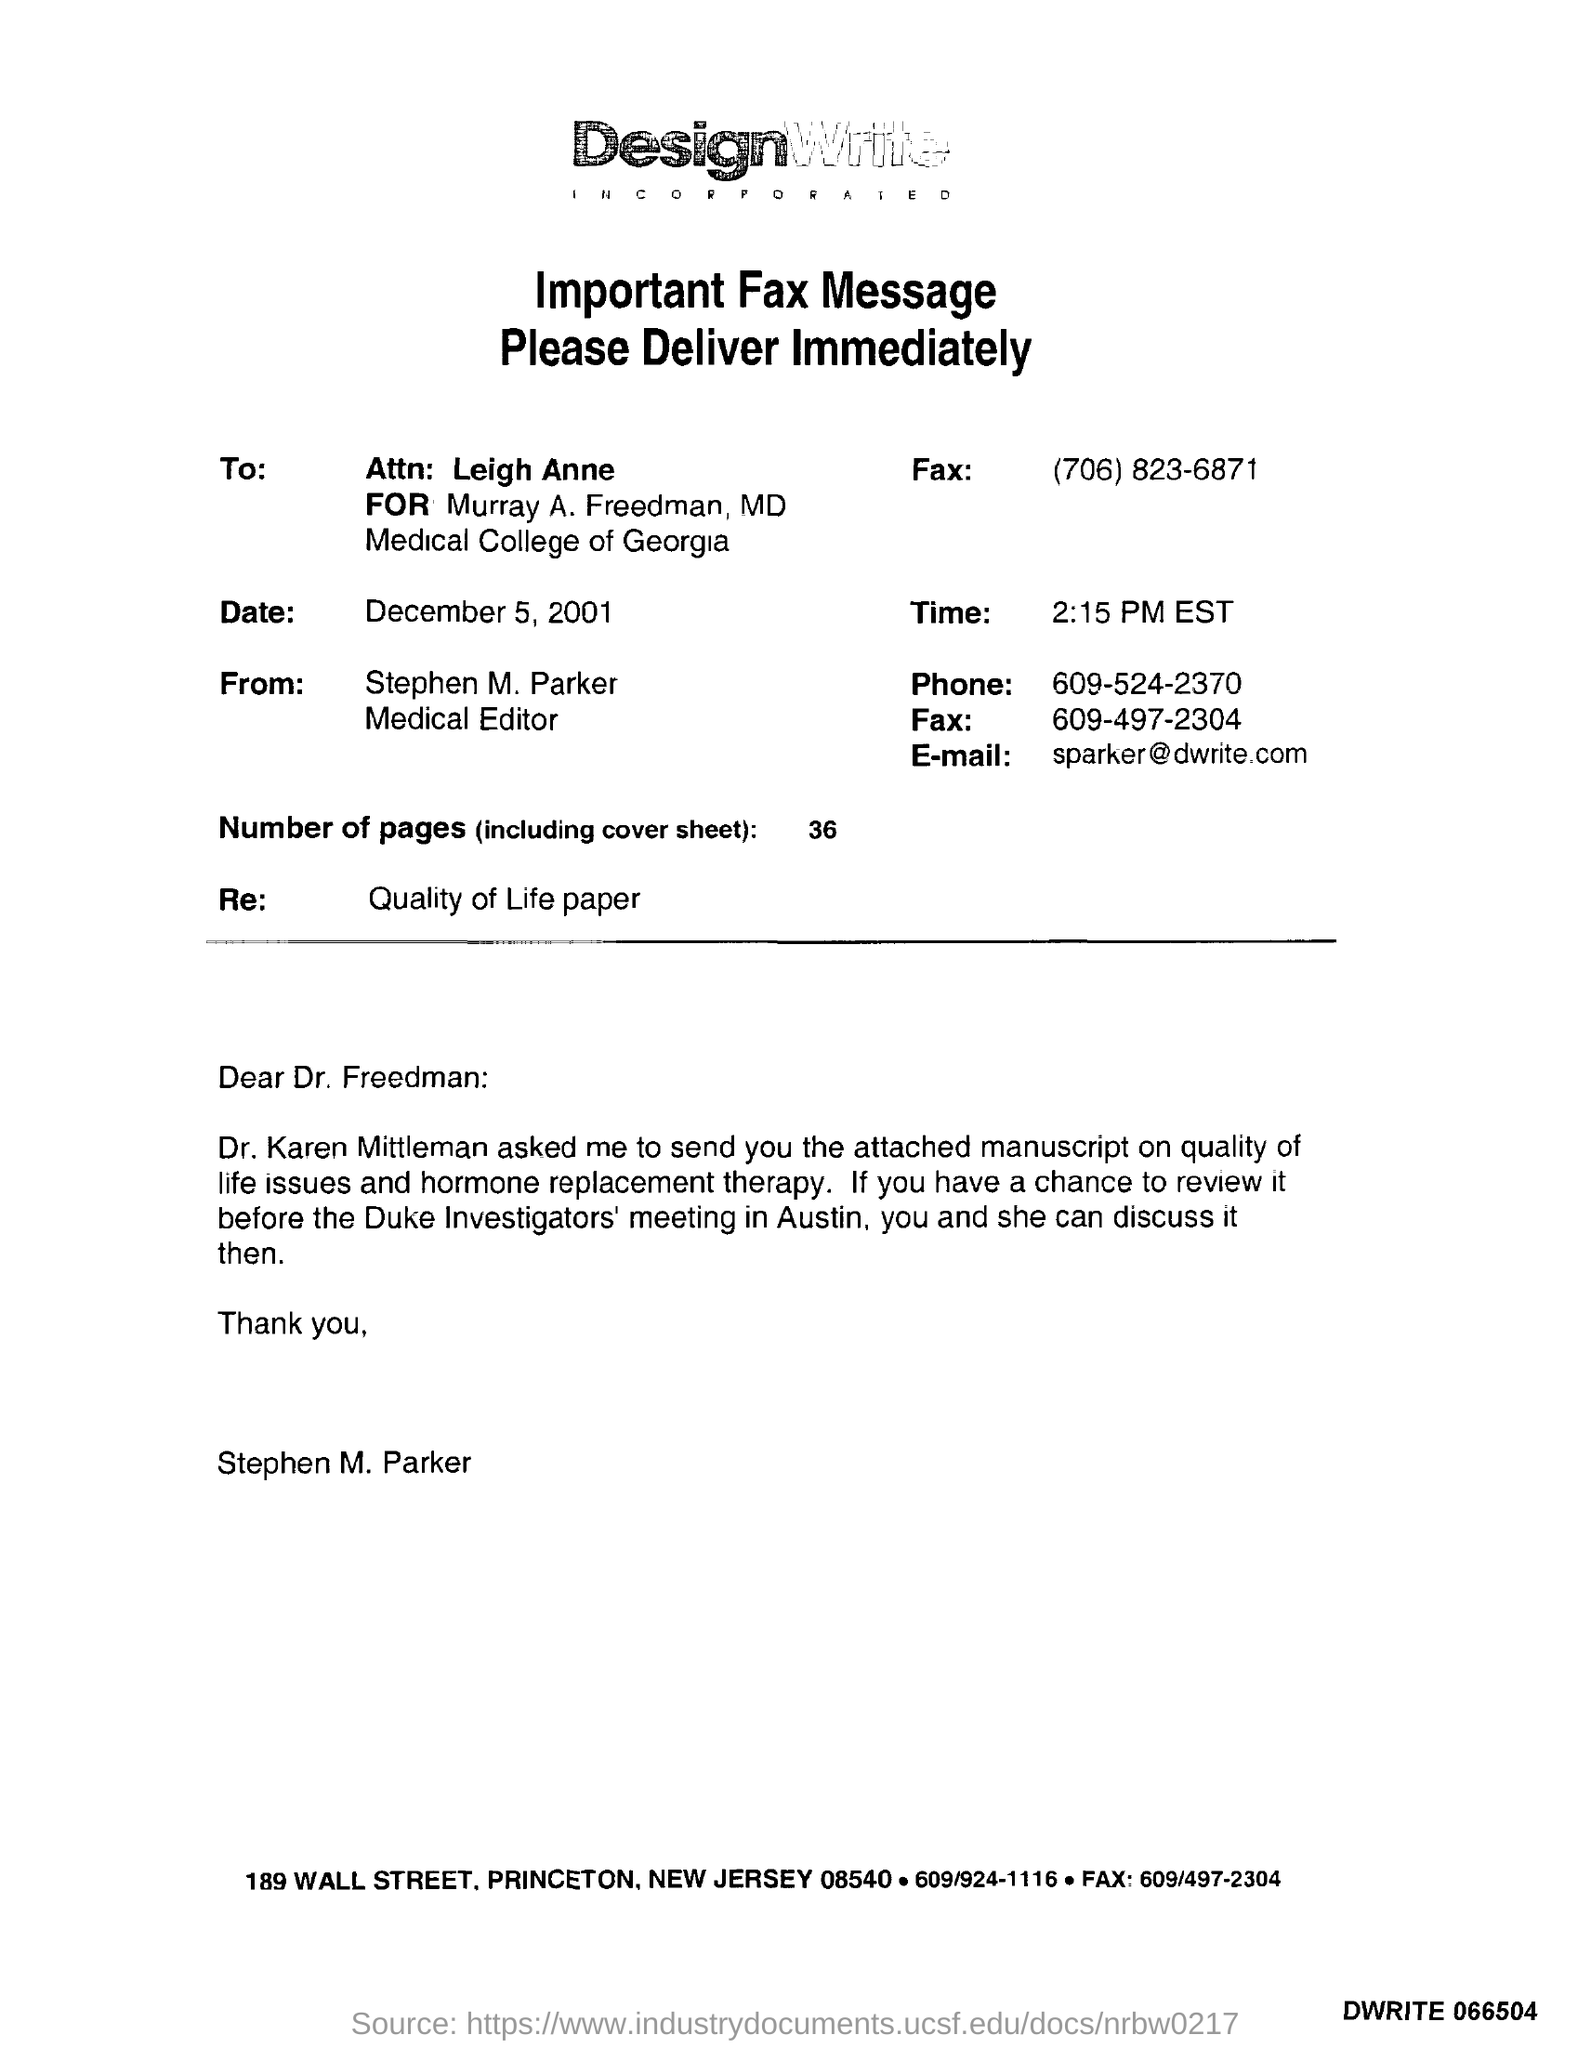Which company's fax is this?
Provide a succinct answer. DesignWrite Incorporated. Who is the sender of the Fax?
Ensure brevity in your answer.  Stephen M. Parker. What is the designation of Stephen M. Parker?
Your answer should be very brief. Medical Editor. What is the Fax No of Stephen M. Parker?
Provide a succinct answer. 609-497-2304. What is the date mentioned in the fax?
Give a very brief answer. December 5 , 2001. What is the time mentioned in the fax?
Keep it short and to the point. 2:15 PM EST. How many pages are there in the fax including cover sheet?
Your response must be concise. 36. What is the Email id of Stephen M. Parker?
Make the answer very short. Sparker@dwrite.com. 